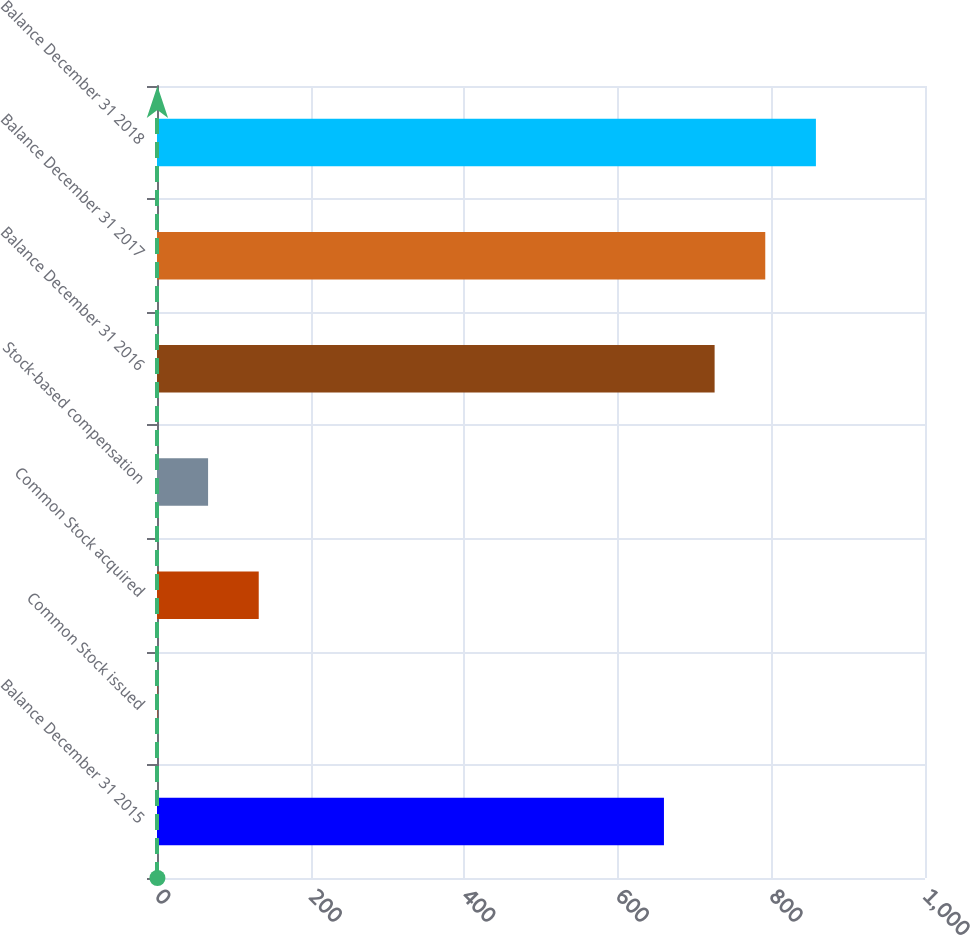Convert chart. <chart><loc_0><loc_0><loc_500><loc_500><bar_chart><fcel>Balance December 31 2015<fcel>Common Stock issued<fcel>Common Stock acquired<fcel>Stock-based compensation<fcel>Balance December 31 2016<fcel>Balance December 31 2017<fcel>Balance December 31 2018<nl><fcel>660.1<fcel>0.55<fcel>132.47<fcel>66.51<fcel>726.06<fcel>792.01<fcel>857.97<nl></chart> 